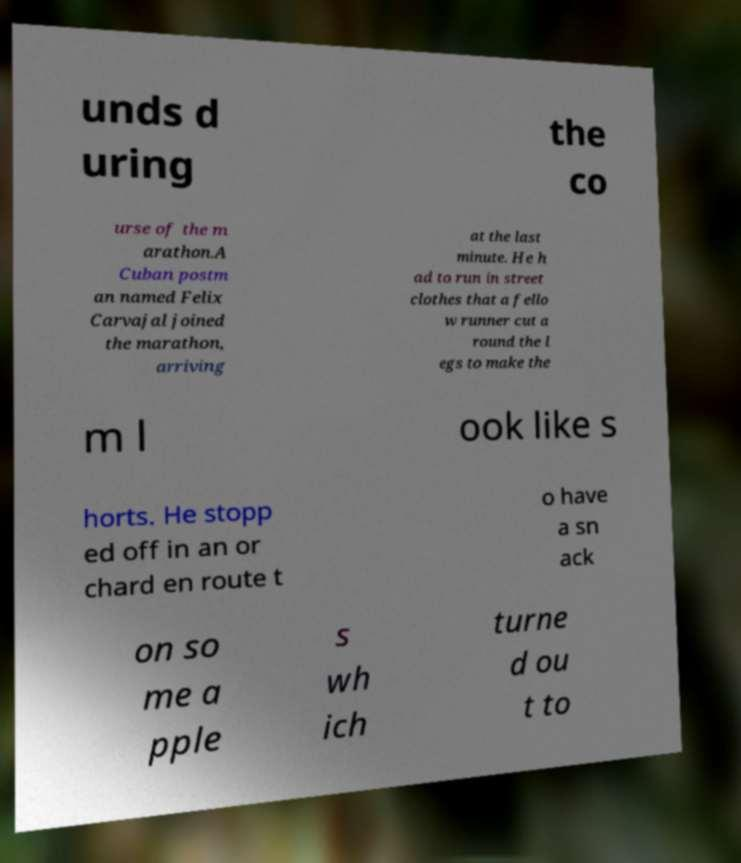I need the written content from this picture converted into text. Can you do that? unds d uring the co urse of the m arathon.A Cuban postm an named Felix Carvajal joined the marathon, arriving at the last minute. He h ad to run in street clothes that a fello w runner cut a round the l egs to make the m l ook like s horts. He stopp ed off in an or chard en route t o have a sn ack on so me a pple s wh ich turne d ou t to 